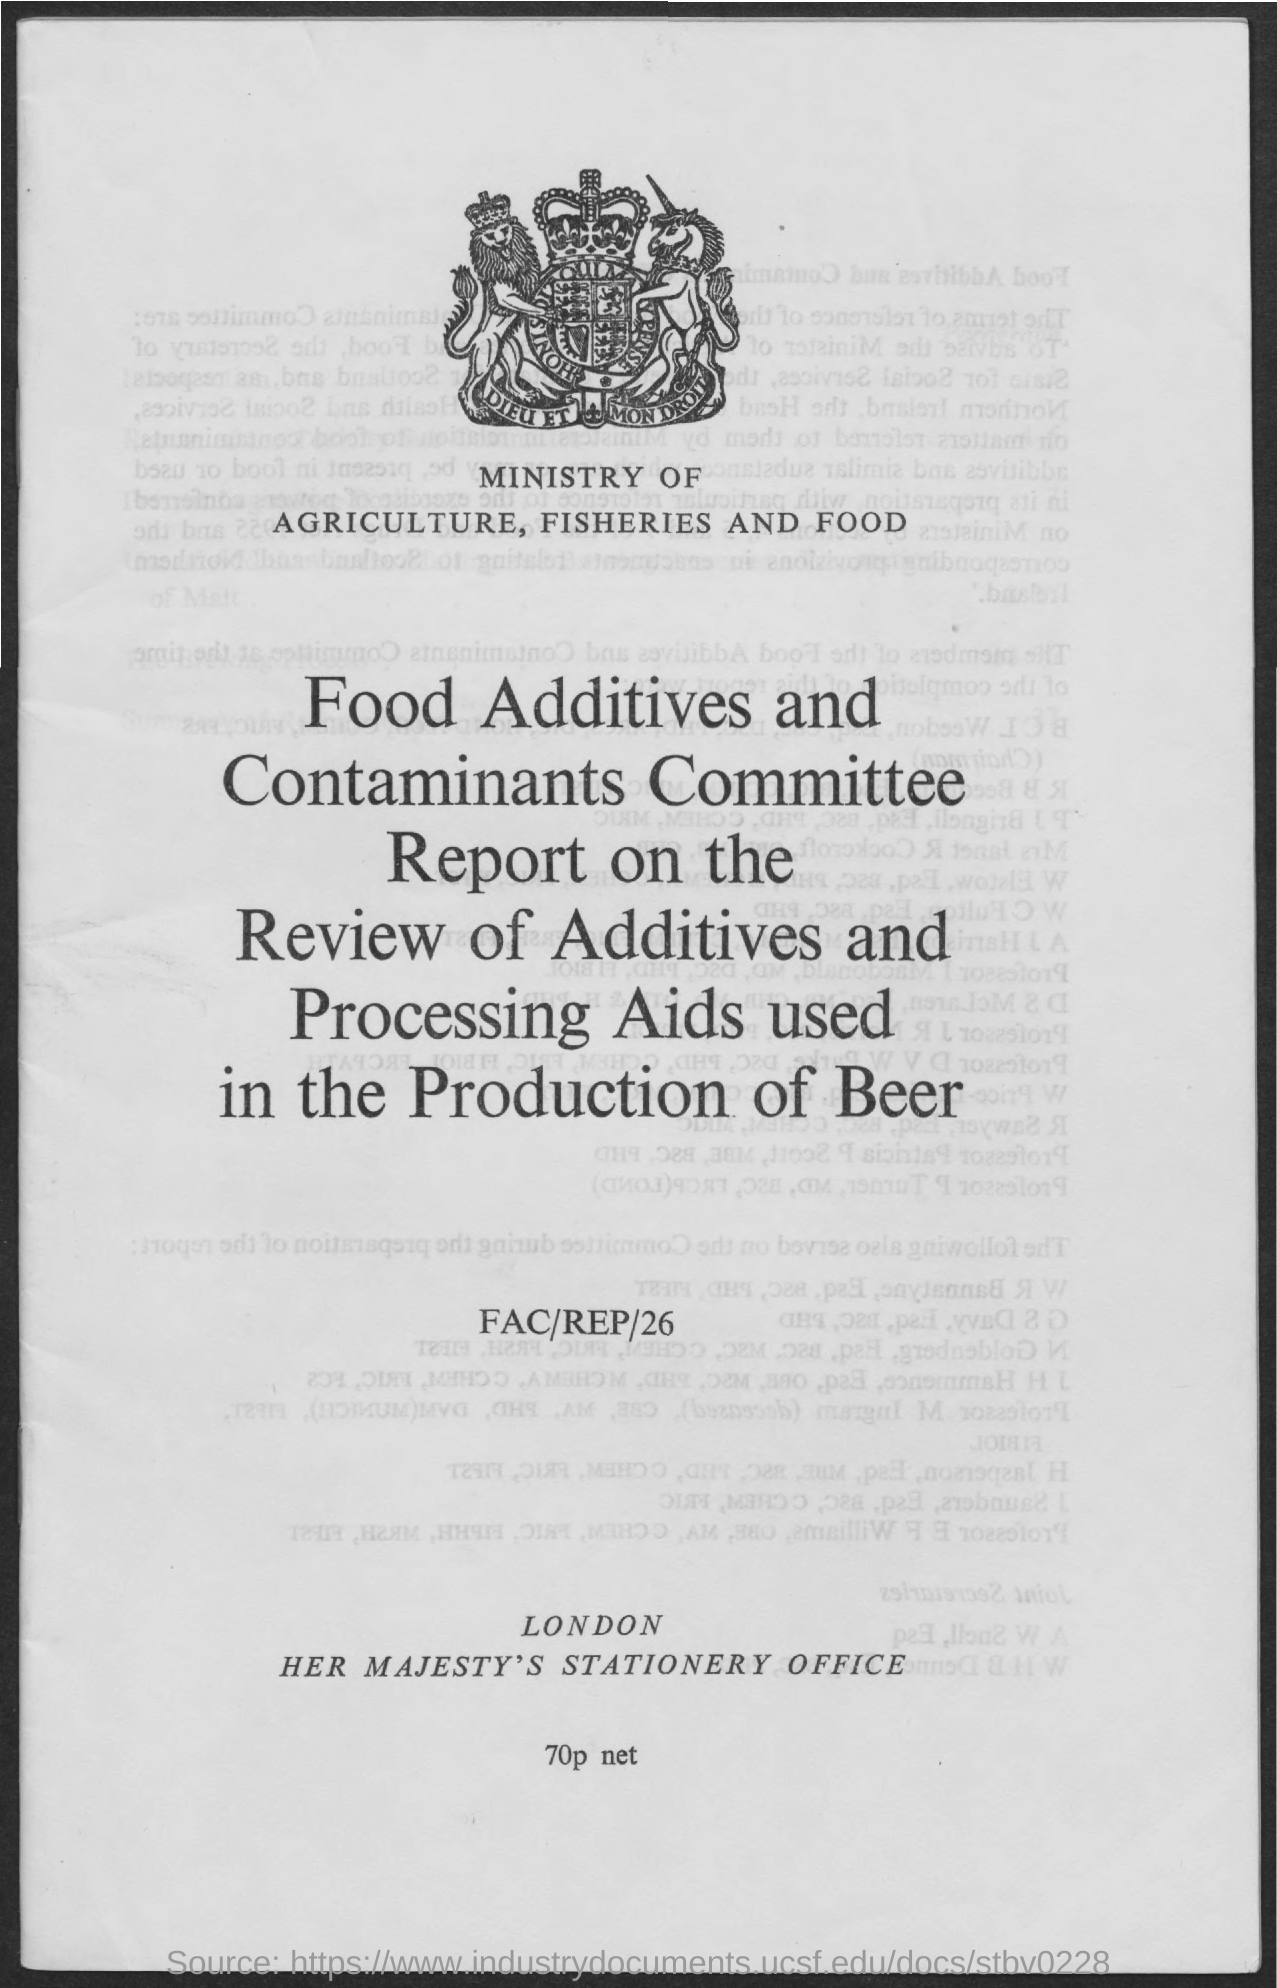What is written below the logo?
Provide a short and direct response. Ministry of agriculture, fisheries and food. 